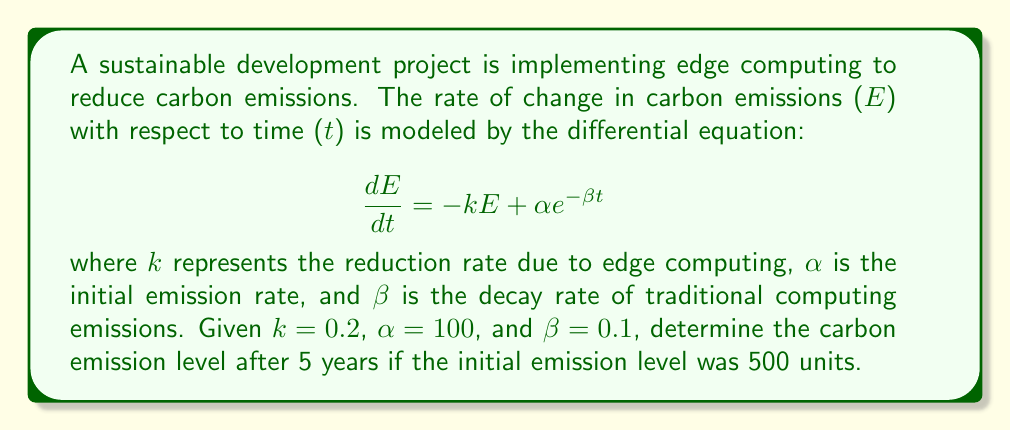Can you solve this math problem? To solve this problem, we need to follow these steps:

1) The given differential equation is a first-order linear differential equation:

   $$\frac{dE}{dt} + kE = \alpha e^{-\beta t}$$

2) The general solution for this type of equation is:

   $$E(t) = e^{-kt} \left( C + \int \alpha e^{-\beta t} e^{kt} dt \right)$$

3) Evaluating the integral:

   $$\int \alpha e^{-\beta t} e^{kt} dt = \alpha \int e^{(k-\beta)t} dt = \frac{\alpha}{k-\beta} e^{(k-\beta)t} + C'$$

4) Substituting back:

   $$E(t) = e^{-kt} \left( C + \frac{\alpha}{k-\beta} e^{(k-\beta)t} \right)$$

5) Simplifying:

   $$E(t) = \frac{\alpha}{k-\beta} e^{-\beta t} + Ce^{-kt}$$

6) Using the initial condition $E(0) = 500$:

   $$500 = \frac{\alpha}{k-\beta} + C$$

   $$C = 500 - \frac{\alpha}{k-\beta} = 500 - \frac{100}{0.2-0.1} = 500 - 1000 = -500$$

7) Therefore, the particular solution is:

   $$E(t) = \frac{100}{0.2-0.1} e^{-0.1t} - 500e^{-0.2t}$$

8) Evaluating at t = 5:

   $$E(5) = 1000 e^{-0.5} - 500e^{-1} \approx 303.26$$
Answer: The carbon emission level after 5 years is approximately 303.26 units. 